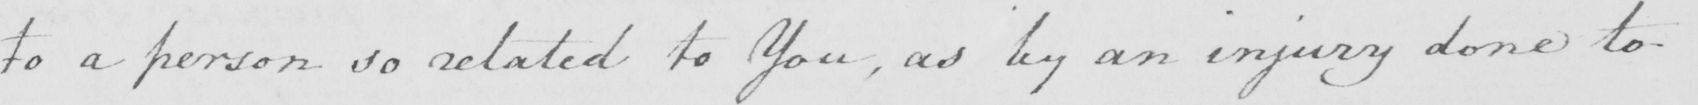What is written in this line of handwriting? to a person so related to You , as by an injury done to 